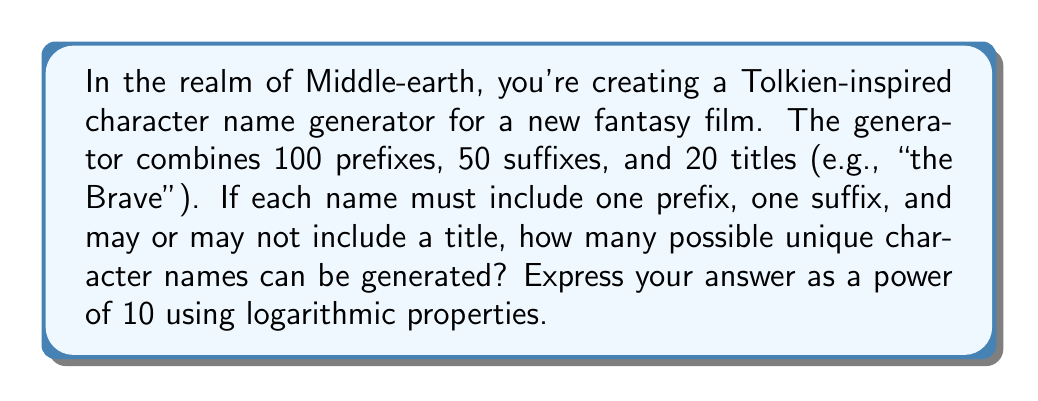Provide a solution to this math problem. Let's approach this step-by-step:

1) First, we need to calculate the total number of possible combinations:
   - 100 prefixes × 50 suffixes = 5000 base names
   - Each base name can either have no title or one of the 20 titles
   - So, we have 5000 × (1 + 20) = 5000 × 21 = 105,000 total combinations

2) Now, we need to express this as a power of 10 using logarithms:
   $105,000 = 10^x$

3) Taking the logarithm of both sides:
   $\log(105,000) = \log(10^x)$

4) Using the logarithm property $\log(10^x) = x\log(10) = x$, we get:
   $\log(105,000) = x$

5) We can split 105,000 using logarithm properties:
   $\log(105,000) = \log(10^5 \times 10,500) = \log(10^5) + \log(10,500)$

6) Simplify:
   $x = 5 + \log(10,500)$

7) Using a calculator or estimation:
   $\log(10,500) \approx 4.021$

8) Therefore:
   $x \approx 5 + 4.021 = 9.021$

So, the number of possible combinations is approximately $10^{9.021}$.
Answer: $10^{9.021}$ 